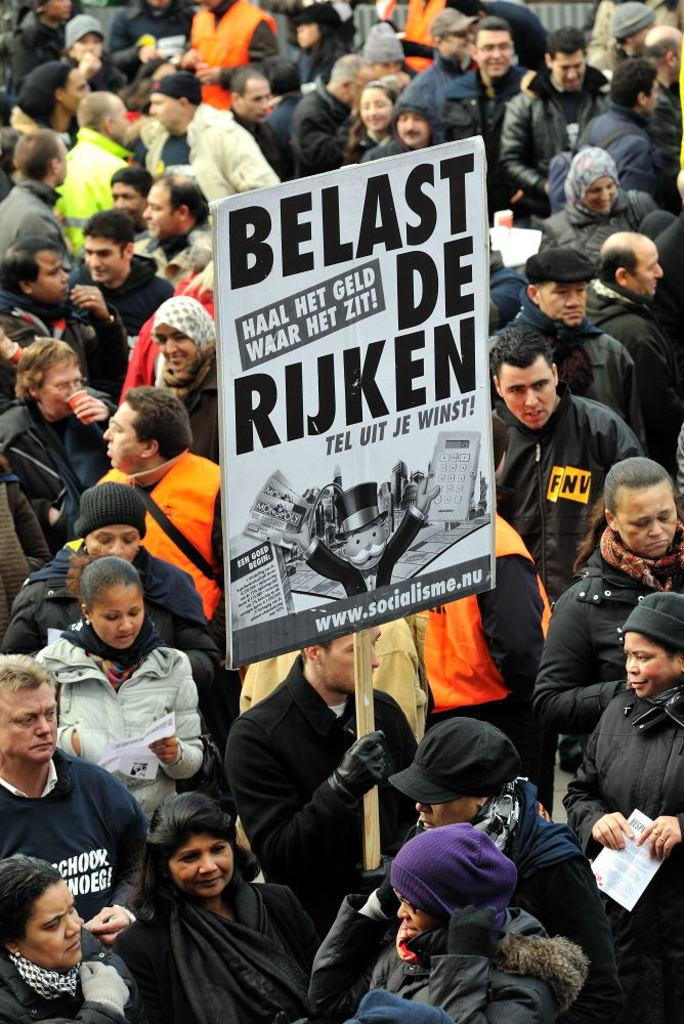What is the person in the image holding? The person in the image is holding a poster. Are there any other people visible in the image? Yes, there are people around the person holding the poster. How many chairs can be seen in the image? There are no chairs visible in the image. What type of coach is present in the image? There is no coach present in the image. 